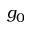Convert formula to latex. <formula><loc_0><loc_0><loc_500><loc_500>g _ { 0 }</formula> 